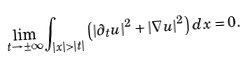Convert formula to latex. <formula><loc_0><loc_0><loc_500><loc_500>\lim _ { t \to \pm \infty } \int _ { | x | > | t | } \left ( | \partial _ { t } u | ^ { 2 } + | \nabla u | ^ { 2 } \right ) d x = 0 .</formula> 